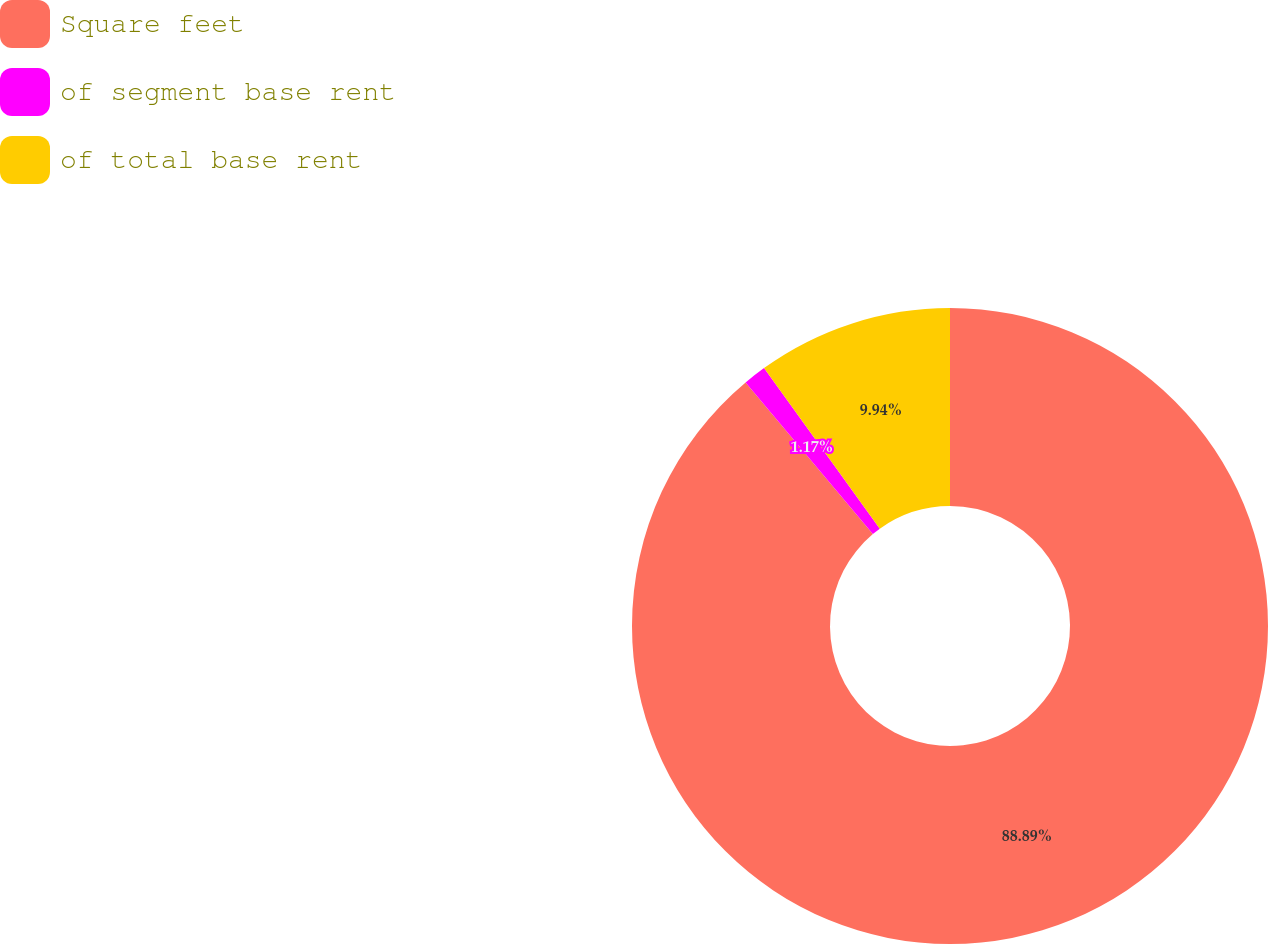Convert chart. <chart><loc_0><loc_0><loc_500><loc_500><pie_chart><fcel>Square feet<fcel>of segment base rent<fcel>of total base rent<nl><fcel>88.88%<fcel>1.17%<fcel>9.94%<nl></chart> 